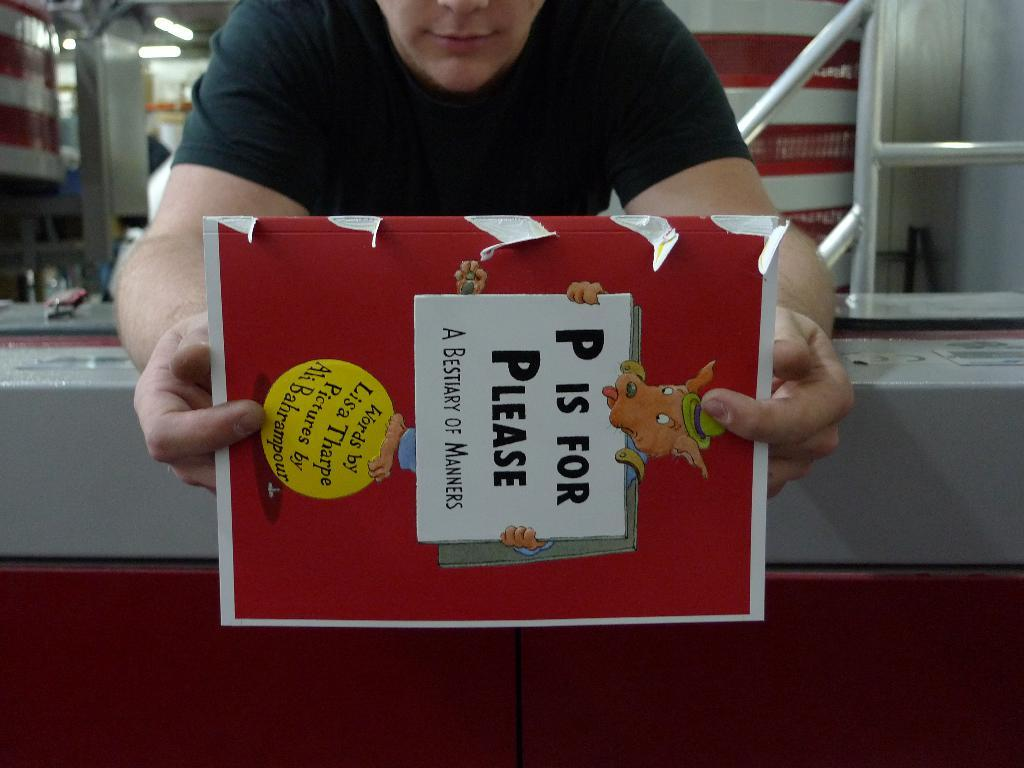What is the main subject of the image? There is a person in the image. What is the person holding in the image? The person is holding a paper with text and a cartoon image. What can be seen in the background of the image? In the background, there are rods and lights visible. Can you describe the setting where the person is located? The person is in front of a wall, and there are other unspecified objects in the background. What type of bed can be seen in the image? There is no bed present in the image. Can you describe the veins visible in the person's arm in the image? There is no visible vein or arm in the image; the person is holding a paper with text and a cartoon image. 